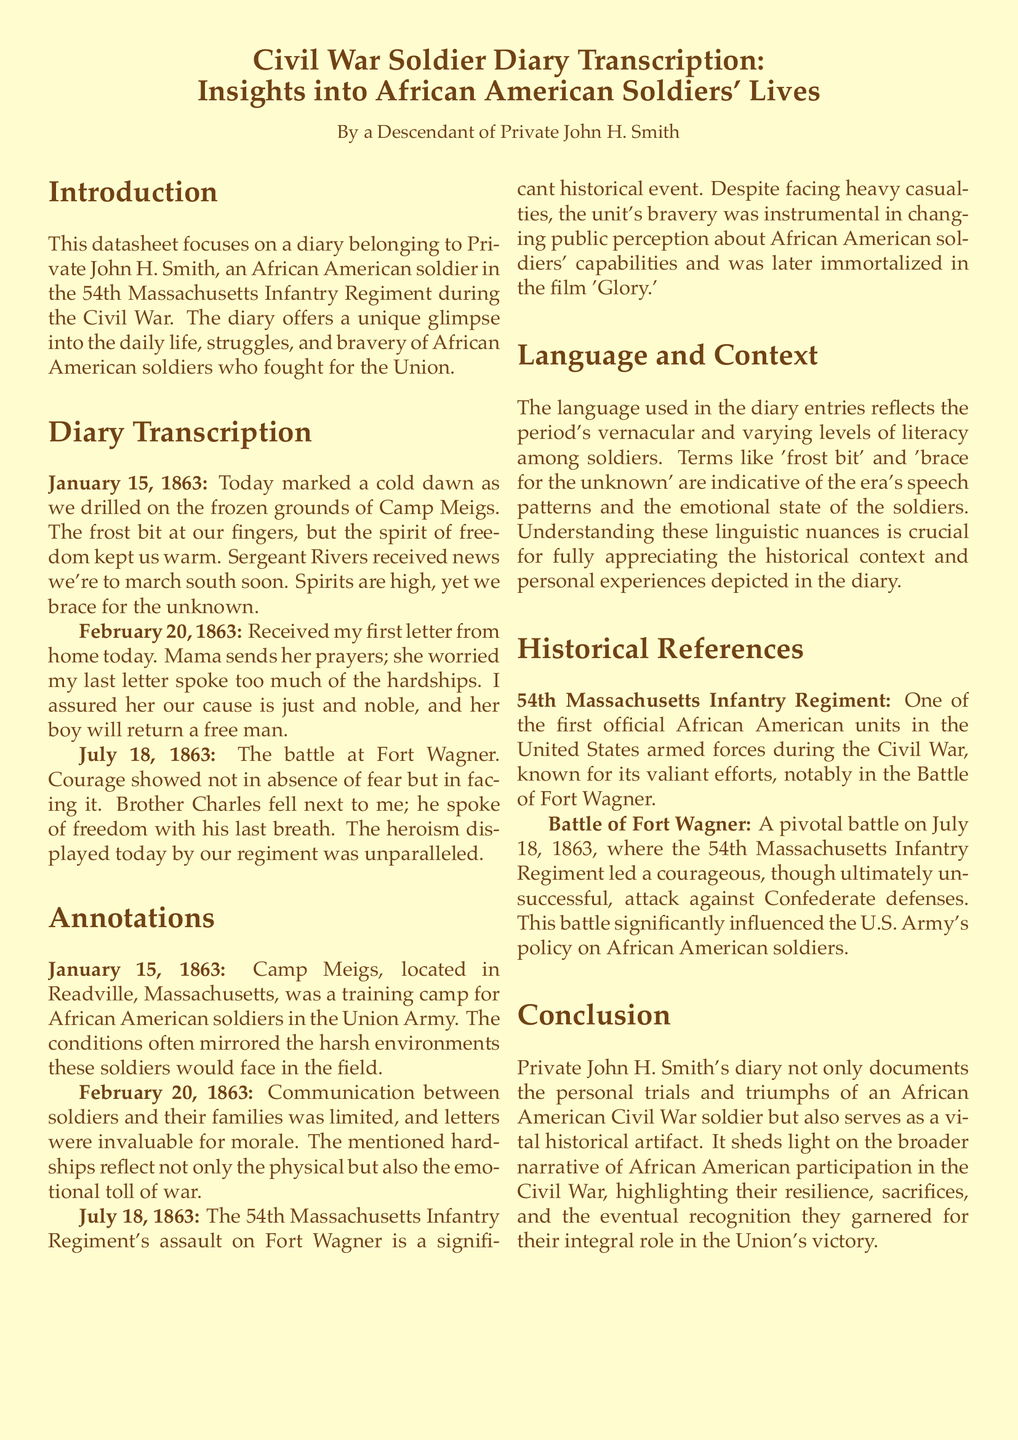what is the name of the soldier whose diary is transcribed? The introduction specifies that the diary belongs to Private John H. Smith.
Answer: Private John H. Smith which regiment did Private John H. Smith serve in? The introduction mentions that he served in the 54th Massachusetts Infantry Regiment.
Answer: 54th Massachusetts Infantry Regiment when did the Battle of Fort Wagner occur? The diary entry notes that the battle took place on July 18, 1863.
Answer: July 18, 1863 what emotional state is reflected in the diary entries? The language in the diary mentions themes of spirit, bravery, and emotional challenges faced by soldiers.
Answer: Emotional challenges why was the communication between soldiers and their families limited? The annotation explains that communication was often restricted, making letters invaluable for soldiers' morale.
Answer: Communication was restricted what historical impact did the 54th Massachusetts Infantry Regiment have? The historical references indicate that their actions influenced public perception about African American soldiers during the Civil War.
Answer: Influenced public perception how does the diary contribute to understanding African American history? The conclusion states that the diary documents the trials and triumphs of African American soldiers, contributing to the broader historical narrative.
Answer: Contributes to the broader historical narrative what is the significance of the phrase 'frost bit'? The language section describes this term as indicative of the era's speech patterns reflecting the hardships faced by soldiers.
Answer: Indicative of the era's speech patterns which camp is mentioned in the diary? The diary states that the soldiers drilled at Camp Meigs.
Answer: Camp Meigs 